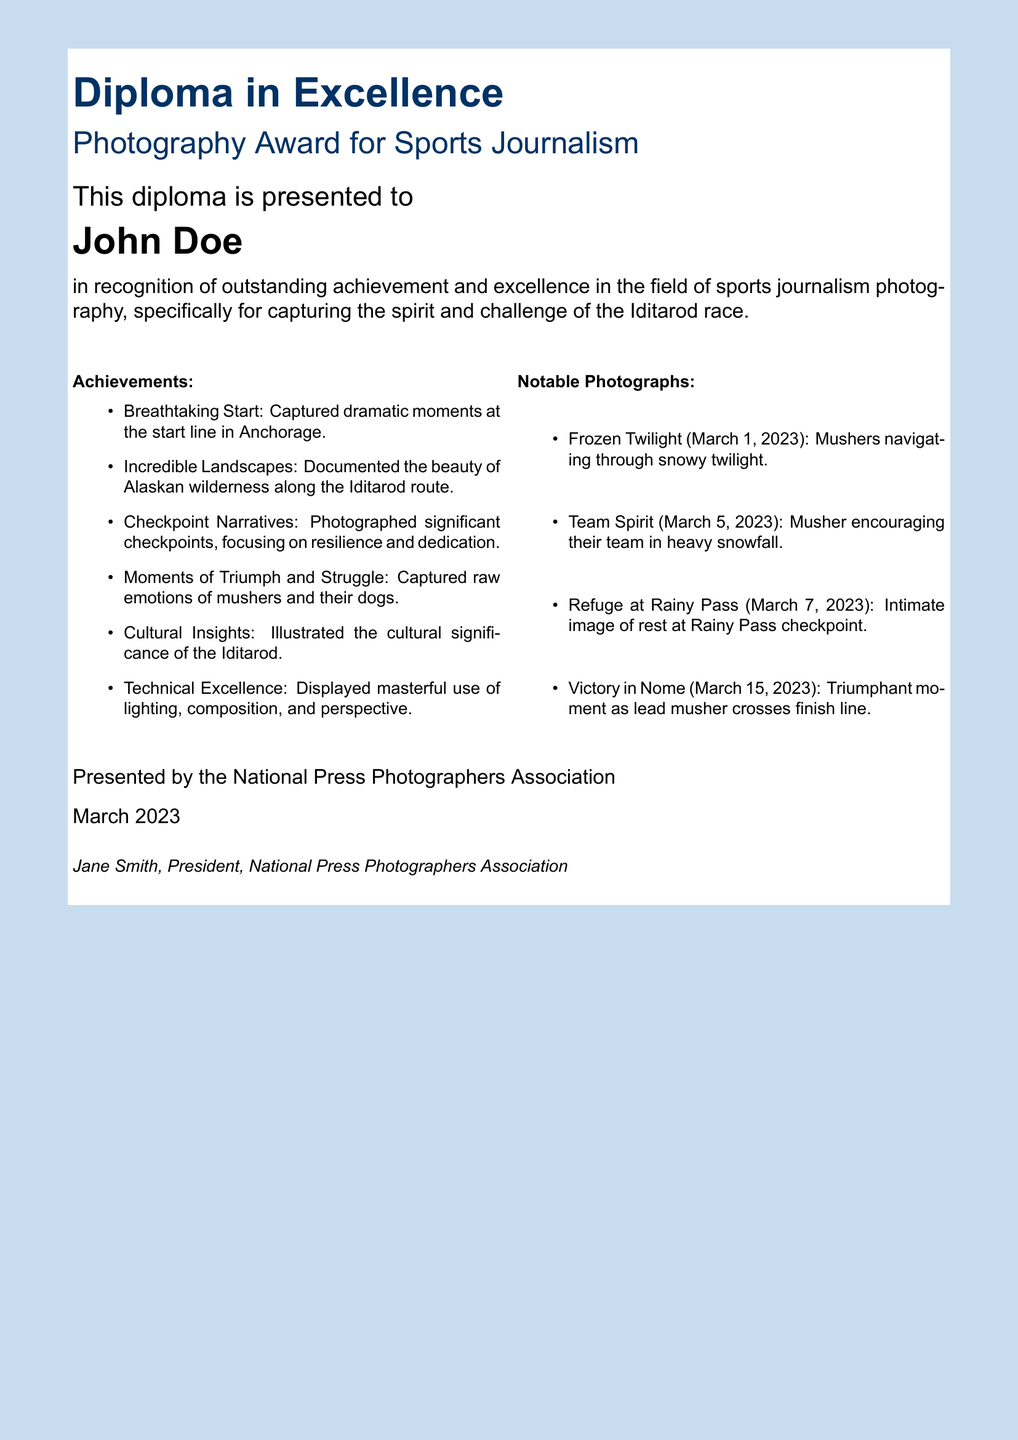What is the title of the diploma? The title of the diploma is presented in bold at the top of the document, which is "Photography Award for Sports Journalism."
Answer: Photography Award for Sports Journalism Who is the diploma awarded to? The name of the person receiving the award is mentioned prominently in the document, which is "John Doe."
Answer: John Doe What organization presented the diploma? The organization that presented the diploma is listed at the bottom of the document, which is the "National Press Photographers Association."
Answer: National Press Photographers Association What date was the diploma presented? The date on the diploma is noted at the bottom, stating it was presented in "March 2023."
Answer: March 2023 How many notable photographs are listed? The document enumerates notable photographs, indicating a total of four by using bullets.
Answer: Four What is a specific achievement mentioned? One of the listed achievements in the document highlights "Captured dramatic moments at the start line in Anchorage."
Answer: Captured dramatic moments at the start line in Anchorage What does the achievement section focus on? The achievements highlight specific areas of excellence which include capturing the "spirit and challenge of the Iditarod race."
Answer: Spirit and challenge of the Iditarod race Name one of the notable photographs. The document lists several photographs, including "Frozen Twilight" as one example.
Answer: Frozen Twilight What emotional aspect did the photographs aim to capture? The document mentions capturing "raw emotions of mushers and their dogs," reflecting the emotional aspect of the images taken.
Answer: Raw emotions of mushers and their dogs 